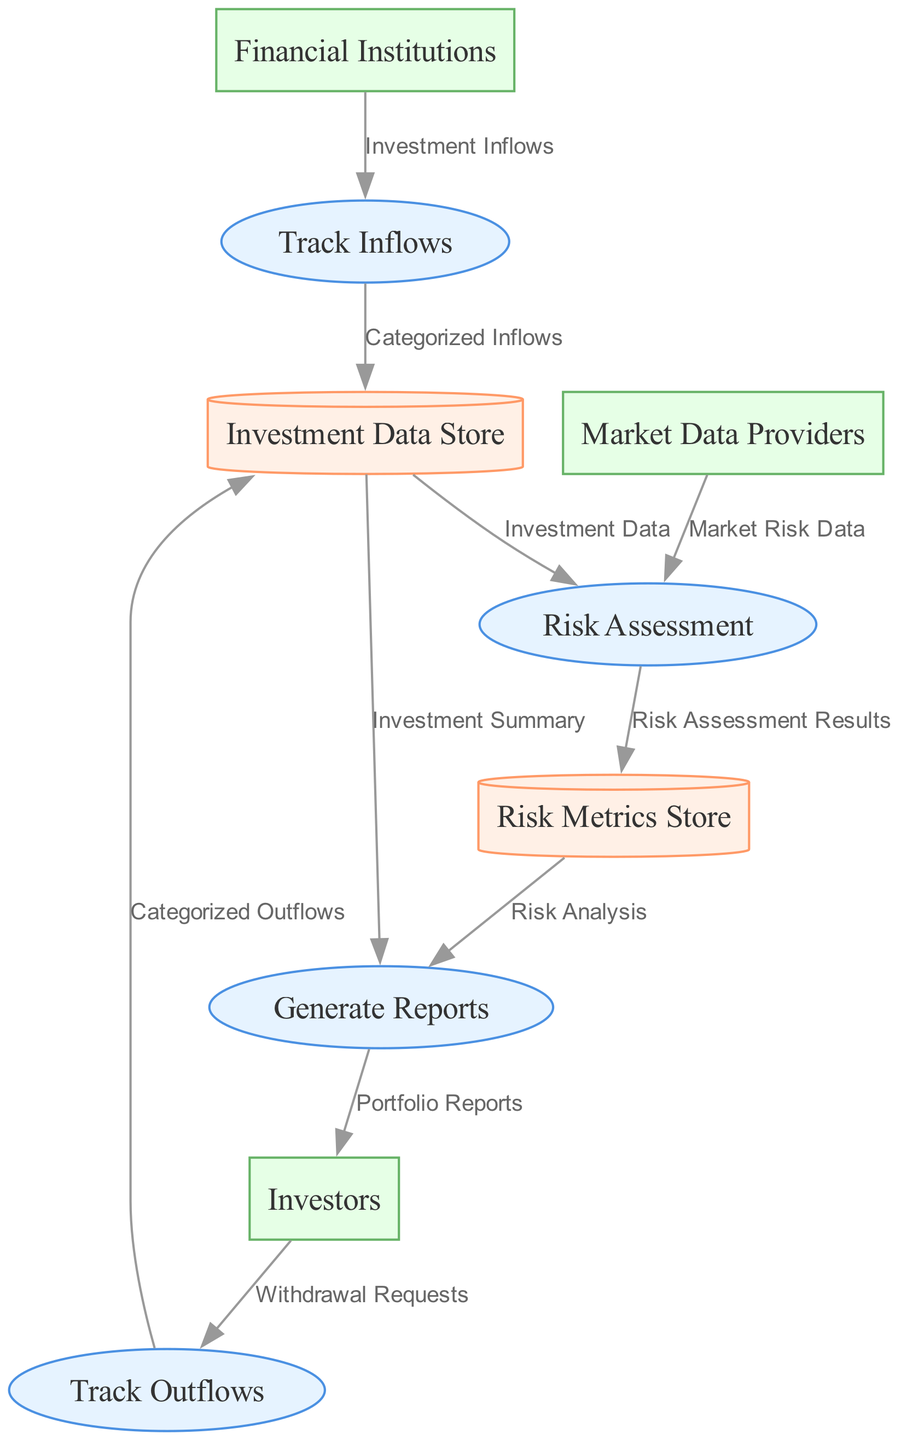What is the name of the process that tracks investment inflows? The diagram shows a process labeled "Track Inflows" which is specifically responsible for this task.
Answer: Track Inflows How many data stores are present in the diagram? The diagram lists two data stores: "Investment Data Store" and "Risk Metrics Store." Therefore, the total is two.
Answer: 2 Which external entity provides market risk data? In the diagram, the external entity labeled "Market Data Providers" is shown to send market risk data to the process for risk assessment.
Answer: Market Data Providers What is the output of the process "Generate Reports"? The process "Generate Reports" outputs "Portfolio Reports" to the external entity "Investors."
Answer: Portfolio Reports How many processes are involved in tracking investment flows? The diagram includes two processes specifically focused on tracking flows: "Track Inflows" and "Track Outflows."
Answer: 2 Which data store receives the categorized inflows? The "Categorized Inflows" from the "Track Inflows" process go to the "Investment Data Store."
Answer: Investment Data Store What type of data is evaluated in the "Risk Assessment" process? The "Risk Assessment" process evaluates "Investment Data" received from the "Investment Data Store" along with "Market Risk Data" from "Market Data Providers."
Answer: Investment Data and Market Risk Data What document is generated based on both investment inflows and risk analysis? The "Generate Reports" process combines data from both "Investment Summary" and "Risk Analysis" to create the final reports.
Answer: Portfolio Reports Which process directly interacts with external investors? The "Generate Reports" process sends results directly to the external entity labeled "Investors," making it the interactive process.
Answer: Generate Reports 